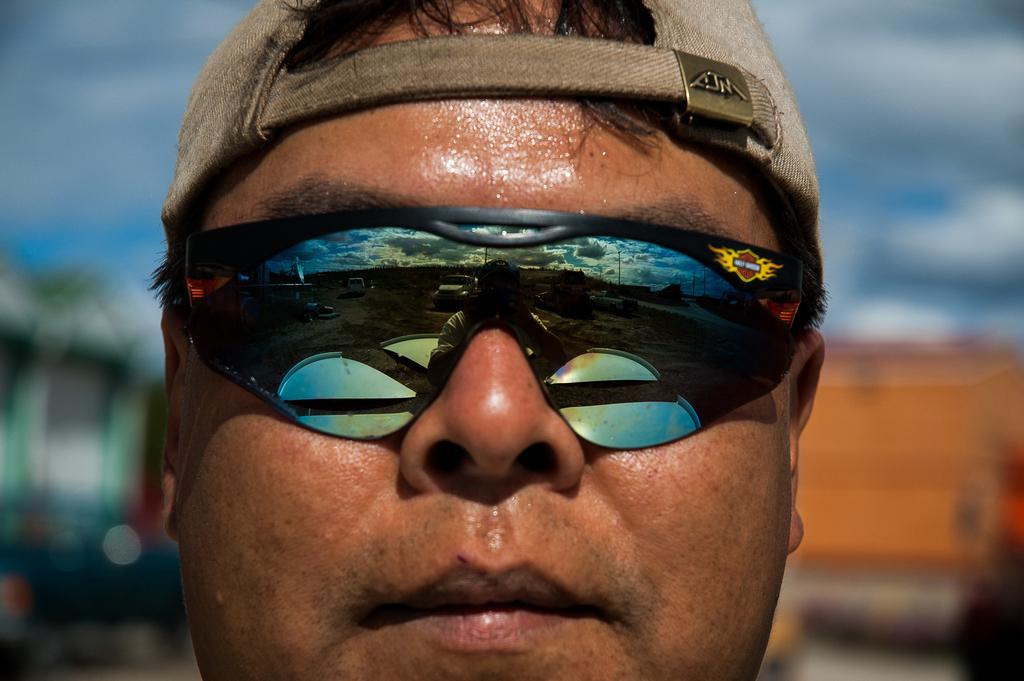In one or two sentences, can you explain what this image depicts? In this picture we can see a cap, face of a man, goggles with the reflection of vehicles on the ground, poles, sky with clouds on it and in the background it is blurry. 